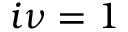Convert formula to latex. <formula><loc_0><loc_0><loc_500><loc_500>i \nu = 1</formula> 